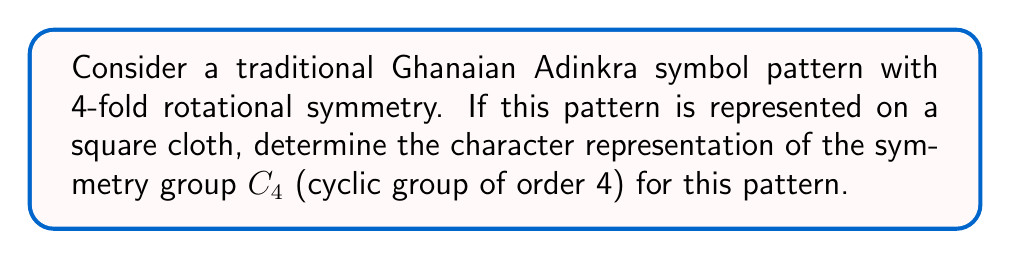Can you solve this math problem? Let's approach this step-by-step:

1) The symmetry group $C_4$ has four elements: $\{e, r, r^2, r^3\}$, where $e$ is the identity and $r$ is a 90-degree rotation.

2) For a 4-fold symmetric Adinkra pattern, we need to consider how each group element affects the pattern:

   - $e$: No change (identity)
   - $r$: 90-degree rotation
   - $r^2$: 180-degree rotation
   - $r^3$: 270-degree rotation

3) The character of a representation is the trace of the matrix representing each group element's action.

4) For a 2D pattern, we can represent these actions as 2x2 matrices:

   $$e = \begin{pmatrix} 1 & 0 \\ 0 & 1 \end{pmatrix}$$
   $$r = \begin{pmatrix} 0 & -1 \\ 1 & 0 \end{pmatrix}$$
   $$r^2 = \begin{pmatrix} -1 & 0 \\ 0 & -1 \end{pmatrix}$$
   $$r^3 = \begin{pmatrix} 0 & 1 \\ -1 & 0 \end{pmatrix}$$

5) The character for each element is the trace of its matrix:

   $\chi(e) = 1 + 1 = 2$
   $\chi(r) = 0 + 0 = 0$
   $\chi(r^2) = -1 + (-1) = -2$
   $\chi(r^3) = 0 + 0 = 0$

6) Therefore, the character representation is $(2, 0, -2, 0)$.
Answer: $(2, 0, -2, 0)$ 